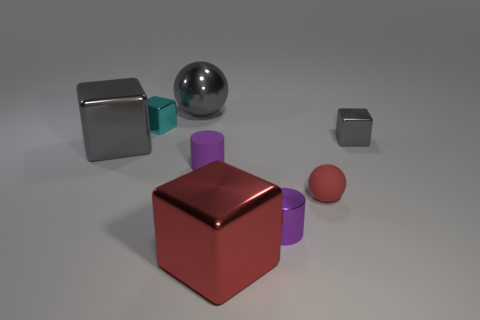What material do the objects in the image appear to be made of? The objects in the image seem to be made of various materials; the cubes and the sphere reflect light in a way that suggests they are made of metal, whereas the cylindrical and smaller spherical objects have a matte finish, indicating a possible plastic or painted metal material. 